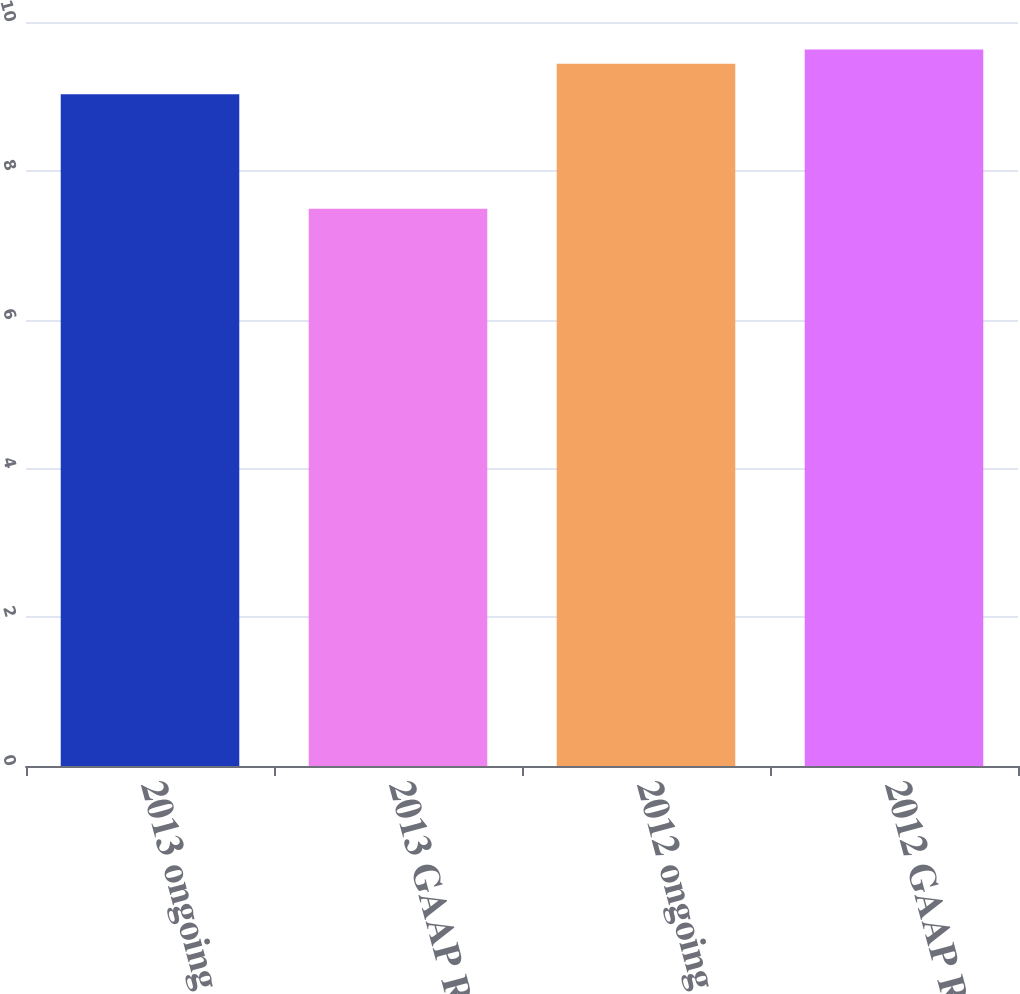Convert chart. <chart><loc_0><loc_0><loc_500><loc_500><bar_chart><fcel>2013 ongoing ROE<fcel>2013 GAAP ROE<fcel>2012 ongoing ROE<fcel>2012 GAAP ROE<nl><fcel>9.03<fcel>7.49<fcel>9.44<fcel>9.63<nl></chart> 